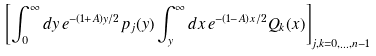<formula> <loc_0><loc_0><loc_500><loc_500>\left [ \int _ { 0 } ^ { \infty } d y \, e ^ { - ( 1 + A ) y / 2 } p _ { j } ( y ) \int _ { y } ^ { \infty } d x \, e ^ { - ( 1 - A ) x / 2 } Q _ { k } ( x ) \right ] _ { j , k = 0 , \dots , n - 1 }</formula> 